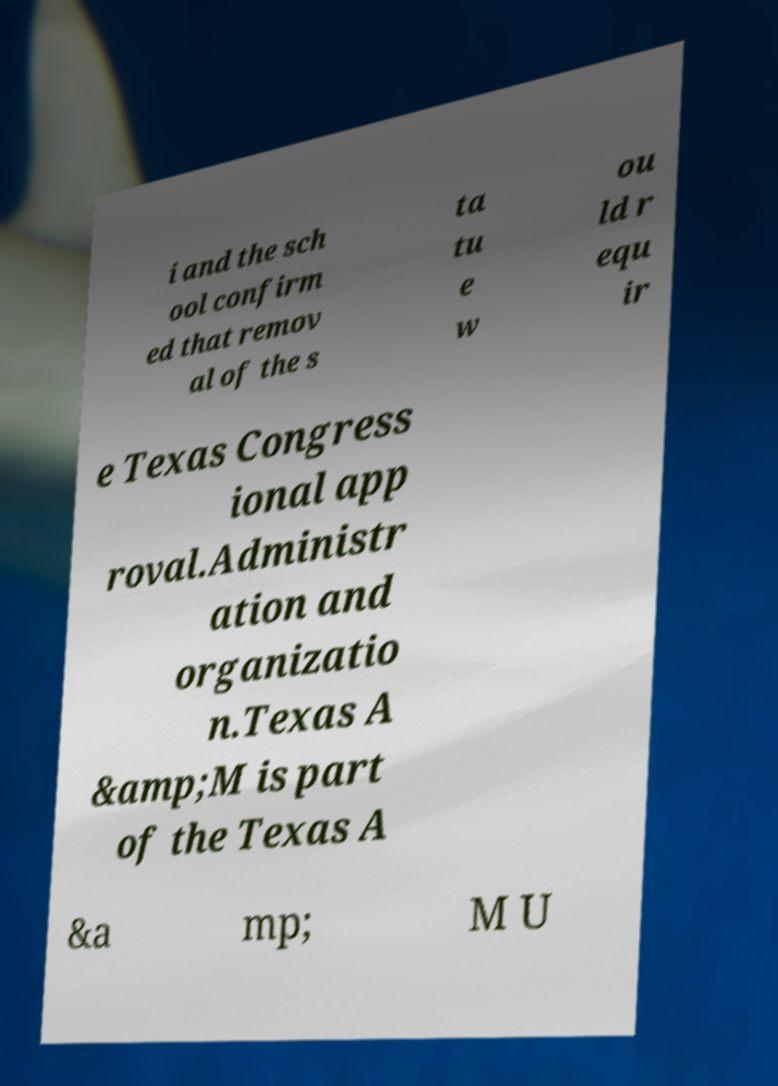There's text embedded in this image that I need extracted. Can you transcribe it verbatim? i and the sch ool confirm ed that remov al of the s ta tu e w ou ld r equ ir e Texas Congress ional app roval.Administr ation and organizatio n.Texas A &amp;M is part of the Texas A &a mp; M U 